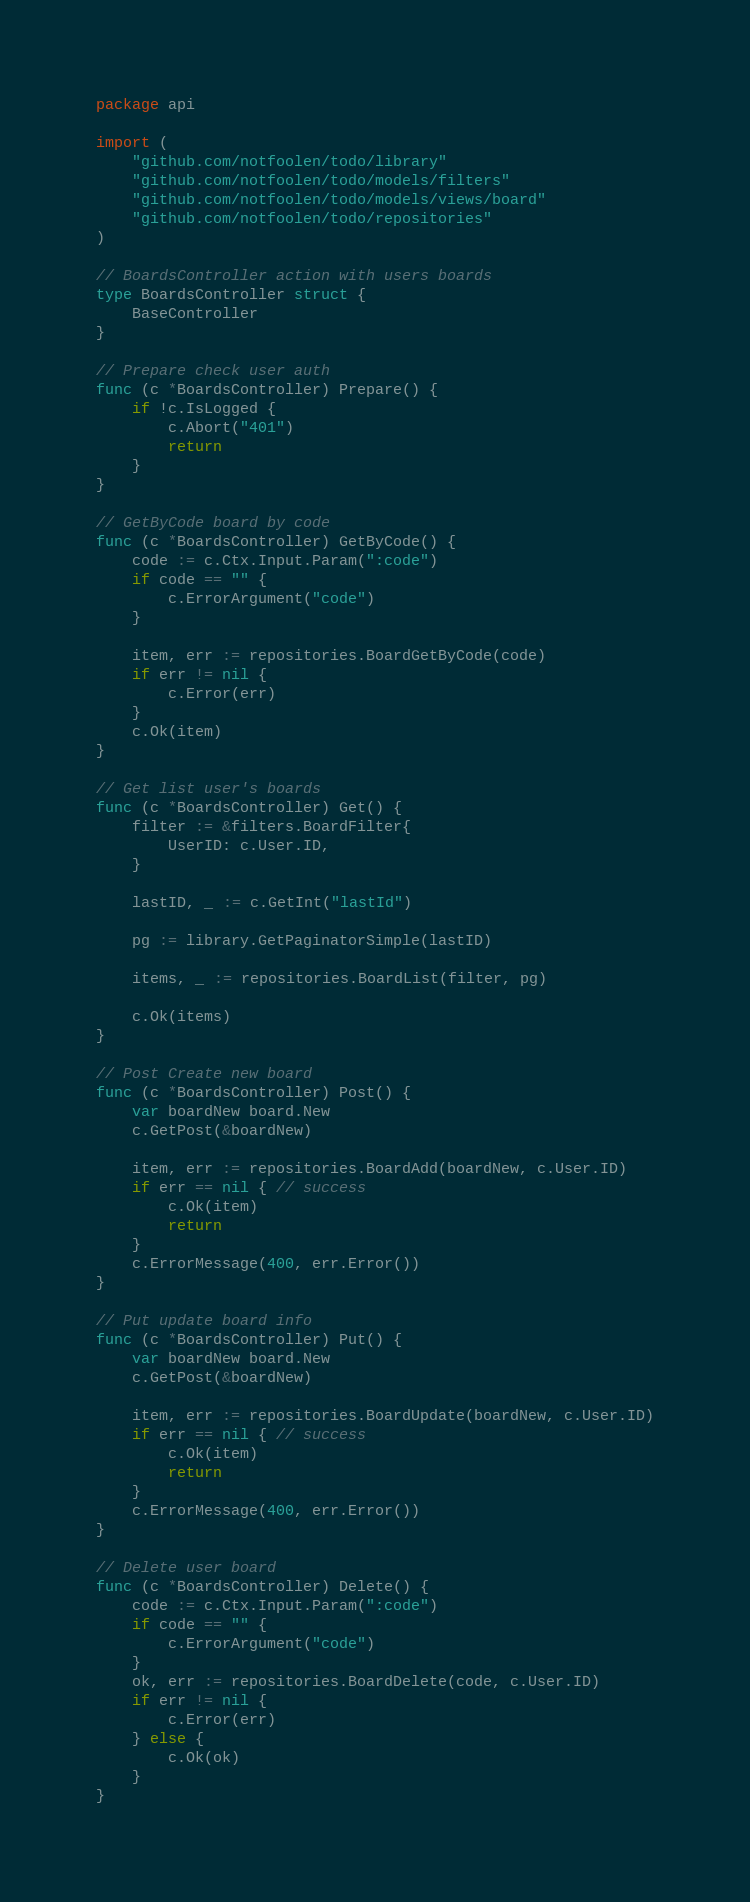Convert code to text. <code><loc_0><loc_0><loc_500><loc_500><_Go_>package api

import (
	"github.com/notfoolen/todo/library"
	"github.com/notfoolen/todo/models/filters"
	"github.com/notfoolen/todo/models/views/board"
	"github.com/notfoolen/todo/repositories"
)

// BoardsController action with users boards
type BoardsController struct {
	BaseController
}

// Prepare check user auth
func (c *BoardsController) Prepare() {
	if !c.IsLogged {
		c.Abort("401")
		return
	}
}

// GetByCode board by code
func (c *BoardsController) GetByCode() {
	code := c.Ctx.Input.Param(":code")
	if code == "" {
		c.ErrorArgument("code")
	}

	item, err := repositories.BoardGetByCode(code)
	if err != nil {
		c.Error(err)
	}
	c.Ok(item)
}

// Get list user's boards
func (c *BoardsController) Get() {
	filter := &filters.BoardFilter{
		UserID: c.User.ID,
	}

	lastID, _ := c.GetInt("lastId")

	pg := library.GetPaginatorSimple(lastID)

	items, _ := repositories.BoardList(filter, pg)

	c.Ok(items)
}

// Post Create new board
func (c *BoardsController) Post() {
	var boardNew board.New
	c.GetPost(&boardNew)

	item, err := repositories.BoardAdd(boardNew, c.User.ID)
	if err == nil { // success
		c.Ok(item)
		return
	}
	c.ErrorMessage(400, err.Error())
}

// Put update board info
func (c *BoardsController) Put() {
	var boardNew board.New
	c.GetPost(&boardNew)

	item, err := repositories.BoardUpdate(boardNew, c.User.ID)
	if err == nil { // success
		c.Ok(item)
		return
	}
	c.ErrorMessage(400, err.Error())
}

// Delete user board
func (c *BoardsController) Delete() {
	code := c.Ctx.Input.Param(":code")
	if code == "" {
		c.ErrorArgument("code")
	}
	ok, err := repositories.BoardDelete(code, c.User.ID)
	if err != nil {
		c.Error(err)
	} else {
		c.Ok(ok)
	}
}
</code> 